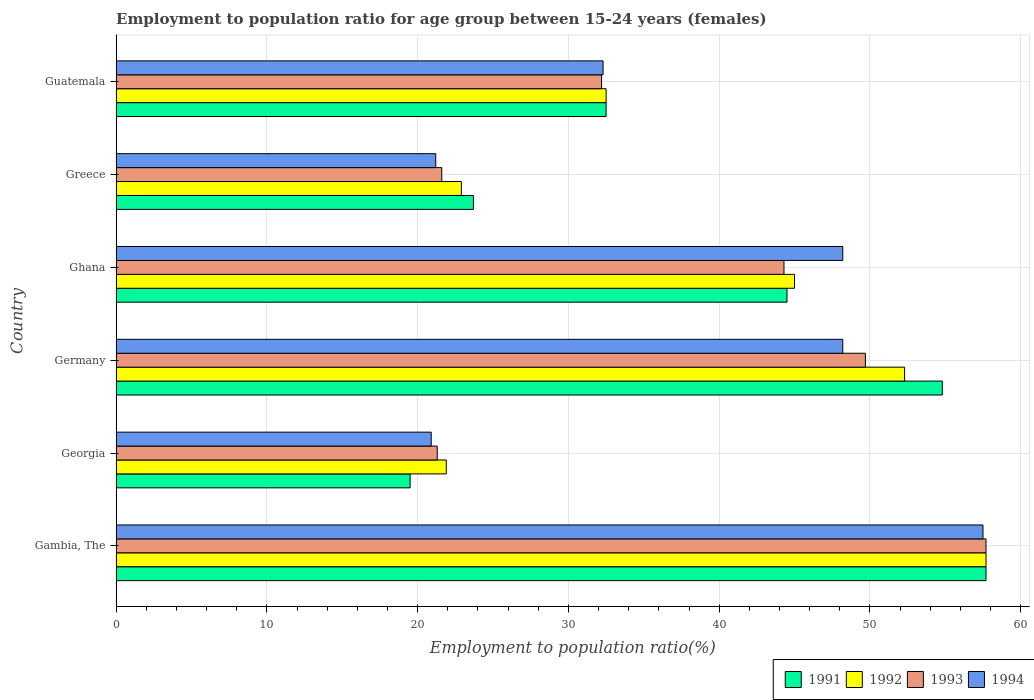Are the number of bars per tick equal to the number of legend labels?
Your answer should be very brief. Yes. In how many cases, is the number of bars for a given country not equal to the number of legend labels?
Your answer should be compact. 0. What is the employment to population ratio in 1994 in Gambia, The?
Give a very brief answer. 57.5. Across all countries, what is the maximum employment to population ratio in 1992?
Your response must be concise. 57.7. Across all countries, what is the minimum employment to population ratio in 1993?
Offer a very short reply. 21.3. In which country was the employment to population ratio in 1994 maximum?
Your answer should be compact. Gambia, The. In which country was the employment to population ratio in 1991 minimum?
Your answer should be compact. Georgia. What is the total employment to population ratio in 1993 in the graph?
Give a very brief answer. 226.8. What is the difference between the employment to population ratio in 1992 in Georgia and that in Germany?
Provide a succinct answer. -30.4. What is the difference between the employment to population ratio in 1992 in Georgia and the employment to population ratio in 1994 in Germany?
Your answer should be compact. -26.3. What is the average employment to population ratio in 1994 per country?
Your answer should be compact. 38.05. What is the difference between the employment to population ratio in 1992 and employment to population ratio in 1993 in Germany?
Your answer should be very brief. 2.6. In how many countries, is the employment to population ratio in 1992 greater than 22 %?
Make the answer very short. 5. What is the ratio of the employment to population ratio in 1991 in Gambia, The to that in Germany?
Ensure brevity in your answer.  1.05. What is the difference between the highest and the second highest employment to population ratio in 1992?
Your response must be concise. 5.4. What is the difference between the highest and the lowest employment to population ratio in 1994?
Provide a succinct answer. 36.6. What does the 2nd bar from the top in Gambia, The represents?
Provide a short and direct response. 1993. What does the 4th bar from the bottom in Germany represents?
Offer a terse response. 1994. How many bars are there?
Make the answer very short. 24. Are all the bars in the graph horizontal?
Your answer should be compact. Yes. Are the values on the major ticks of X-axis written in scientific E-notation?
Give a very brief answer. No. Does the graph contain any zero values?
Provide a succinct answer. No. Does the graph contain grids?
Offer a very short reply. Yes. Where does the legend appear in the graph?
Provide a short and direct response. Bottom right. How many legend labels are there?
Your answer should be compact. 4. How are the legend labels stacked?
Keep it short and to the point. Horizontal. What is the title of the graph?
Offer a very short reply. Employment to population ratio for age group between 15-24 years (females). What is the label or title of the X-axis?
Provide a short and direct response. Employment to population ratio(%). What is the Employment to population ratio(%) in 1991 in Gambia, The?
Provide a succinct answer. 57.7. What is the Employment to population ratio(%) of 1992 in Gambia, The?
Make the answer very short. 57.7. What is the Employment to population ratio(%) in 1993 in Gambia, The?
Your response must be concise. 57.7. What is the Employment to population ratio(%) in 1994 in Gambia, The?
Provide a short and direct response. 57.5. What is the Employment to population ratio(%) in 1991 in Georgia?
Give a very brief answer. 19.5. What is the Employment to population ratio(%) in 1992 in Georgia?
Give a very brief answer. 21.9. What is the Employment to population ratio(%) of 1993 in Georgia?
Provide a succinct answer. 21.3. What is the Employment to population ratio(%) of 1994 in Georgia?
Give a very brief answer. 20.9. What is the Employment to population ratio(%) of 1991 in Germany?
Ensure brevity in your answer.  54.8. What is the Employment to population ratio(%) of 1992 in Germany?
Ensure brevity in your answer.  52.3. What is the Employment to population ratio(%) of 1993 in Germany?
Offer a very short reply. 49.7. What is the Employment to population ratio(%) of 1994 in Germany?
Ensure brevity in your answer.  48.2. What is the Employment to population ratio(%) in 1991 in Ghana?
Ensure brevity in your answer.  44.5. What is the Employment to population ratio(%) in 1993 in Ghana?
Provide a short and direct response. 44.3. What is the Employment to population ratio(%) of 1994 in Ghana?
Offer a terse response. 48.2. What is the Employment to population ratio(%) in 1991 in Greece?
Ensure brevity in your answer.  23.7. What is the Employment to population ratio(%) in 1992 in Greece?
Give a very brief answer. 22.9. What is the Employment to population ratio(%) of 1993 in Greece?
Keep it short and to the point. 21.6. What is the Employment to population ratio(%) of 1994 in Greece?
Your response must be concise. 21.2. What is the Employment to population ratio(%) of 1991 in Guatemala?
Provide a succinct answer. 32.5. What is the Employment to population ratio(%) in 1992 in Guatemala?
Provide a short and direct response. 32.5. What is the Employment to population ratio(%) in 1993 in Guatemala?
Provide a short and direct response. 32.2. What is the Employment to population ratio(%) of 1994 in Guatemala?
Your answer should be very brief. 32.3. Across all countries, what is the maximum Employment to population ratio(%) of 1991?
Ensure brevity in your answer.  57.7. Across all countries, what is the maximum Employment to population ratio(%) of 1992?
Provide a succinct answer. 57.7. Across all countries, what is the maximum Employment to population ratio(%) in 1993?
Ensure brevity in your answer.  57.7. Across all countries, what is the maximum Employment to population ratio(%) of 1994?
Give a very brief answer. 57.5. Across all countries, what is the minimum Employment to population ratio(%) of 1991?
Give a very brief answer. 19.5. Across all countries, what is the minimum Employment to population ratio(%) of 1992?
Your answer should be compact. 21.9. Across all countries, what is the minimum Employment to population ratio(%) in 1993?
Provide a succinct answer. 21.3. Across all countries, what is the minimum Employment to population ratio(%) of 1994?
Your response must be concise. 20.9. What is the total Employment to population ratio(%) in 1991 in the graph?
Your response must be concise. 232.7. What is the total Employment to population ratio(%) in 1992 in the graph?
Give a very brief answer. 232.3. What is the total Employment to population ratio(%) in 1993 in the graph?
Your response must be concise. 226.8. What is the total Employment to population ratio(%) in 1994 in the graph?
Offer a terse response. 228.3. What is the difference between the Employment to population ratio(%) in 1991 in Gambia, The and that in Georgia?
Your response must be concise. 38.2. What is the difference between the Employment to population ratio(%) of 1992 in Gambia, The and that in Georgia?
Offer a very short reply. 35.8. What is the difference between the Employment to population ratio(%) of 1993 in Gambia, The and that in Georgia?
Offer a very short reply. 36.4. What is the difference between the Employment to population ratio(%) in 1994 in Gambia, The and that in Georgia?
Make the answer very short. 36.6. What is the difference between the Employment to population ratio(%) in 1994 in Gambia, The and that in Germany?
Your response must be concise. 9.3. What is the difference between the Employment to population ratio(%) of 1991 in Gambia, The and that in Ghana?
Offer a terse response. 13.2. What is the difference between the Employment to population ratio(%) of 1992 in Gambia, The and that in Ghana?
Provide a succinct answer. 12.7. What is the difference between the Employment to population ratio(%) in 1993 in Gambia, The and that in Ghana?
Your answer should be compact. 13.4. What is the difference between the Employment to population ratio(%) of 1992 in Gambia, The and that in Greece?
Your answer should be compact. 34.8. What is the difference between the Employment to population ratio(%) of 1993 in Gambia, The and that in Greece?
Make the answer very short. 36.1. What is the difference between the Employment to population ratio(%) of 1994 in Gambia, The and that in Greece?
Ensure brevity in your answer.  36.3. What is the difference between the Employment to population ratio(%) of 1991 in Gambia, The and that in Guatemala?
Make the answer very short. 25.2. What is the difference between the Employment to population ratio(%) in 1992 in Gambia, The and that in Guatemala?
Offer a very short reply. 25.2. What is the difference between the Employment to population ratio(%) of 1993 in Gambia, The and that in Guatemala?
Provide a succinct answer. 25.5. What is the difference between the Employment to population ratio(%) of 1994 in Gambia, The and that in Guatemala?
Offer a terse response. 25.2. What is the difference between the Employment to population ratio(%) in 1991 in Georgia and that in Germany?
Provide a succinct answer. -35.3. What is the difference between the Employment to population ratio(%) in 1992 in Georgia and that in Germany?
Keep it short and to the point. -30.4. What is the difference between the Employment to population ratio(%) of 1993 in Georgia and that in Germany?
Give a very brief answer. -28.4. What is the difference between the Employment to population ratio(%) of 1994 in Georgia and that in Germany?
Give a very brief answer. -27.3. What is the difference between the Employment to population ratio(%) in 1991 in Georgia and that in Ghana?
Give a very brief answer. -25. What is the difference between the Employment to population ratio(%) in 1992 in Georgia and that in Ghana?
Ensure brevity in your answer.  -23.1. What is the difference between the Employment to population ratio(%) in 1993 in Georgia and that in Ghana?
Provide a succinct answer. -23. What is the difference between the Employment to population ratio(%) of 1994 in Georgia and that in Ghana?
Make the answer very short. -27.3. What is the difference between the Employment to population ratio(%) in 1993 in Georgia and that in Greece?
Your response must be concise. -0.3. What is the difference between the Employment to population ratio(%) in 1991 in Georgia and that in Guatemala?
Offer a terse response. -13. What is the difference between the Employment to population ratio(%) of 1992 in Georgia and that in Guatemala?
Your response must be concise. -10.6. What is the difference between the Employment to population ratio(%) in 1993 in Georgia and that in Guatemala?
Offer a very short reply. -10.9. What is the difference between the Employment to population ratio(%) of 1994 in Georgia and that in Guatemala?
Provide a short and direct response. -11.4. What is the difference between the Employment to population ratio(%) in 1991 in Germany and that in Ghana?
Ensure brevity in your answer.  10.3. What is the difference between the Employment to population ratio(%) of 1993 in Germany and that in Ghana?
Your response must be concise. 5.4. What is the difference between the Employment to population ratio(%) in 1994 in Germany and that in Ghana?
Ensure brevity in your answer.  0. What is the difference between the Employment to population ratio(%) of 1991 in Germany and that in Greece?
Provide a succinct answer. 31.1. What is the difference between the Employment to population ratio(%) of 1992 in Germany and that in Greece?
Keep it short and to the point. 29.4. What is the difference between the Employment to population ratio(%) of 1993 in Germany and that in Greece?
Keep it short and to the point. 28.1. What is the difference between the Employment to population ratio(%) in 1994 in Germany and that in Greece?
Provide a succinct answer. 27. What is the difference between the Employment to population ratio(%) of 1991 in Germany and that in Guatemala?
Your response must be concise. 22.3. What is the difference between the Employment to population ratio(%) of 1992 in Germany and that in Guatemala?
Offer a very short reply. 19.8. What is the difference between the Employment to population ratio(%) of 1993 in Germany and that in Guatemala?
Your answer should be very brief. 17.5. What is the difference between the Employment to population ratio(%) of 1994 in Germany and that in Guatemala?
Give a very brief answer. 15.9. What is the difference between the Employment to population ratio(%) of 1991 in Ghana and that in Greece?
Keep it short and to the point. 20.8. What is the difference between the Employment to population ratio(%) of 1992 in Ghana and that in Greece?
Ensure brevity in your answer.  22.1. What is the difference between the Employment to population ratio(%) of 1993 in Ghana and that in Greece?
Give a very brief answer. 22.7. What is the difference between the Employment to population ratio(%) in 1994 in Ghana and that in Greece?
Give a very brief answer. 27. What is the difference between the Employment to population ratio(%) in 1993 in Ghana and that in Guatemala?
Your answer should be compact. 12.1. What is the difference between the Employment to population ratio(%) in 1994 in Ghana and that in Guatemala?
Provide a succinct answer. 15.9. What is the difference between the Employment to population ratio(%) of 1993 in Greece and that in Guatemala?
Your answer should be compact. -10.6. What is the difference between the Employment to population ratio(%) in 1994 in Greece and that in Guatemala?
Your answer should be very brief. -11.1. What is the difference between the Employment to population ratio(%) in 1991 in Gambia, The and the Employment to population ratio(%) in 1992 in Georgia?
Your response must be concise. 35.8. What is the difference between the Employment to population ratio(%) in 1991 in Gambia, The and the Employment to population ratio(%) in 1993 in Georgia?
Provide a short and direct response. 36.4. What is the difference between the Employment to population ratio(%) of 1991 in Gambia, The and the Employment to population ratio(%) of 1994 in Georgia?
Provide a succinct answer. 36.8. What is the difference between the Employment to population ratio(%) of 1992 in Gambia, The and the Employment to population ratio(%) of 1993 in Georgia?
Offer a very short reply. 36.4. What is the difference between the Employment to population ratio(%) in 1992 in Gambia, The and the Employment to population ratio(%) in 1994 in Georgia?
Ensure brevity in your answer.  36.8. What is the difference between the Employment to population ratio(%) in 1993 in Gambia, The and the Employment to population ratio(%) in 1994 in Georgia?
Your answer should be compact. 36.8. What is the difference between the Employment to population ratio(%) of 1991 in Gambia, The and the Employment to population ratio(%) of 1993 in Germany?
Offer a very short reply. 8. What is the difference between the Employment to population ratio(%) of 1991 in Gambia, The and the Employment to population ratio(%) of 1994 in Germany?
Provide a short and direct response. 9.5. What is the difference between the Employment to population ratio(%) of 1992 in Gambia, The and the Employment to population ratio(%) of 1993 in Germany?
Your answer should be very brief. 8. What is the difference between the Employment to population ratio(%) in 1991 in Gambia, The and the Employment to population ratio(%) in 1992 in Ghana?
Ensure brevity in your answer.  12.7. What is the difference between the Employment to population ratio(%) of 1993 in Gambia, The and the Employment to population ratio(%) of 1994 in Ghana?
Make the answer very short. 9.5. What is the difference between the Employment to population ratio(%) in 1991 in Gambia, The and the Employment to population ratio(%) in 1992 in Greece?
Your answer should be very brief. 34.8. What is the difference between the Employment to population ratio(%) of 1991 in Gambia, The and the Employment to population ratio(%) of 1993 in Greece?
Give a very brief answer. 36.1. What is the difference between the Employment to population ratio(%) in 1991 in Gambia, The and the Employment to population ratio(%) in 1994 in Greece?
Offer a terse response. 36.5. What is the difference between the Employment to population ratio(%) in 1992 in Gambia, The and the Employment to population ratio(%) in 1993 in Greece?
Keep it short and to the point. 36.1. What is the difference between the Employment to population ratio(%) in 1992 in Gambia, The and the Employment to population ratio(%) in 1994 in Greece?
Provide a short and direct response. 36.5. What is the difference between the Employment to population ratio(%) in 1993 in Gambia, The and the Employment to population ratio(%) in 1994 in Greece?
Your answer should be compact. 36.5. What is the difference between the Employment to population ratio(%) in 1991 in Gambia, The and the Employment to population ratio(%) in 1992 in Guatemala?
Your answer should be very brief. 25.2. What is the difference between the Employment to population ratio(%) of 1991 in Gambia, The and the Employment to population ratio(%) of 1993 in Guatemala?
Provide a succinct answer. 25.5. What is the difference between the Employment to population ratio(%) of 1991 in Gambia, The and the Employment to population ratio(%) of 1994 in Guatemala?
Give a very brief answer. 25.4. What is the difference between the Employment to population ratio(%) of 1992 in Gambia, The and the Employment to population ratio(%) of 1994 in Guatemala?
Your answer should be compact. 25.4. What is the difference between the Employment to population ratio(%) of 1993 in Gambia, The and the Employment to population ratio(%) of 1994 in Guatemala?
Provide a short and direct response. 25.4. What is the difference between the Employment to population ratio(%) of 1991 in Georgia and the Employment to population ratio(%) of 1992 in Germany?
Provide a succinct answer. -32.8. What is the difference between the Employment to population ratio(%) in 1991 in Georgia and the Employment to population ratio(%) in 1993 in Germany?
Ensure brevity in your answer.  -30.2. What is the difference between the Employment to population ratio(%) of 1991 in Georgia and the Employment to population ratio(%) of 1994 in Germany?
Provide a short and direct response. -28.7. What is the difference between the Employment to population ratio(%) in 1992 in Georgia and the Employment to population ratio(%) in 1993 in Germany?
Offer a terse response. -27.8. What is the difference between the Employment to population ratio(%) in 1992 in Georgia and the Employment to population ratio(%) in 1994 in Germany?
Make the answer very short. -26.3. What is the difference between the Employment to population ratio(%) in 1993 in Georgia and the Employment to population ratio(%) in 1994 in Germany?
Provide a succinct answer. -26.9. What is the difference between the Employment to population ratio(%) of 1991 in Georgia and the Employment to population ratio(%) of 1992 in Ghana?
Make the answer very short. -25.5. What is the difference between the Employment to population ratio(%) of 1991 in Georgia and the Employment to population ratio(%) of 1993 in Ghana?
Your answer should be compact. -24.8. What is the difference between the Employment to population ratio(%) of 1991 in Georgia and the Employment to population ratio(%) of 1994 in Ghana?
Make the answer very short. -28.7. What is the difference between the Employment to population ratio(%) of 1992 in Georgia and the Employment to population ratio(%) of 1993 in Ghana?
Ensure brevity in your answer.  -22.4. What is the difference between the Employment to population ratio(%) of 1992 in Georgia and the Employment to population ratio(%) of 1994 in Ghana?
Make the answer very short. -26.3. What is the difference between the Employment to population ratio(%) in 1993 in Georgia and the Employment to population ratio(%) in 1994 in Ghana?
Provide a short and direct response. -26.9. What is the difference between the Employment to population ratio(%) of 1991 in Georgia and the Employment to population ratio(%) of 1992 in Greece?
Provide a succinct answer. -3.4. What is the difference between the Employment to population ratio(%) in 1991 in Georgia and the Employment to population ratio(%) in 1994 in Greece?
Your answer should be compact. -1.7. What is the difference between the Employment to population ratio(%) in 1992 in Georgia and the Employment to population ratio(%) in 1994 in Greece?
Offer a very short reply. 0.7. What is the difference between the Employment to population ratio(%) in 1991 in Georgia and the Employment to population ratio(%) in 1992 in Guatemala?
Ensure brevity in your answer.  -13. What is the difference between the Employment to population ratio(%) in 1991 in Georgia and the Employment to population ratio(%) in 1994 in Guatemala?
Make the answer very short. -12.8. What is the difference between the Employment to population ratio(%) in 1992 in Georgia and the Employment to population ratio(%) in 1993 in Guatemala?
Offer a very short reply. -10.3. What is the difference between the Employment to population ratio(%) in 1991 in Germany and the Employment to population ratio(%) in 1992 in Ghana?
Offer a terse response. 9.8. What is the difference between the Employment to population ratio(%) of 1991 in Germany and the Employment to population ratio(%) of 1992 in Greece?
Keep it short and to the point. 31.9. What is the difference between the Employment to population ratio(%) in 1991 in Germany and the Employment to population ratio(%) in 1993 in Greece?
Your answer should be very brief. 33.2. What is the difference between the Employment to population ratio(%) in 1991 in Germany and the Employment to population ratio(%) in 1994 in Greece?
Offer a terse response. 33.6. What is the difference between the Employment to population ratio(%) in 1992 in Germany and the Employment to population ratio(%) in 1993 in Greece?
Your answer should be compact. 30.7. What is the difference between the Employment to population ratio(%) in 1992 in Germany and the Employment to population ratio(%) in 1994 in Greece?
Your response must be concise. 31.1. What is the difference between the Employment to population ratio(%) in 1993 in Germany and the Employment to population ratio(%) in 1994 in Greece?
Your answer should be compact. 28.5. What is the difference between the Employment to population ratio(%) in 1991 in Germany and the Employment to population ratio(%) in 1992 in Guatemala?
Give a very brief answer. 22.3. What is the difference between the Employment to population ratio(%) in 1991 in Germany and the Employment to population ratio(%) in 1993 in Guatemala?
Offer a terse response. 22.6. What is the difference between the Employment to population ratio(%) in 1991 in Germany and the Employment to population ratio(%) in 1994 in Guatemala?
Provide a short and direct response. 22.5. What is the difference between the Employment to population ratio(%) of 1992 in Germany and the Employment to population ratio(%) of 1993 in Guatemala?
Provide a short and direct response. 20.1. What is the difference between the Employment to population ratio(%) of 1993 in Germany and the Employment to population ratio(%) of 1994 in Guatemala?
Make the answer very short. 17.4. What is the difference between the Employment to population ratio(%) of 1991 in Ghana and the Employment to population ratio(%) of 1992 in Greece?
Provide a short and direct response. 21.6. What is the difference between the Employment to population ratio(%) in 1991 in Ghana and the Employment to population ratio(%) in 1993 in Greece?
Your answer should be very brief. 22.9. What is the difference between the Employment to population ratio(%) of 1991 in Ghana and the Employment to population ratio(%) of 1994 in Greece?
Keep it short and to the point. 23.3. What is the difference between the Employment to population ratio(%) of 1992 in Ghana and the Employment to population ratio(%) of 1993 in Greece?
Your response must be concise. 23.4. What is the difference between the Employment to population ratio(%) of 1992 in Ghana and the Employment to population ratio(%) of 1994 in Greece?
Your answer should be compact. 23.8. What is the difference between the Employment to population ratio(%) of 1993 in Ghana and the Employment to population ratio(%) of 1994 in Greece?
Offer a terse response. 23.1. What is the difference between the Employment to population ratio(%) in 1991 in Ghana and the Employment to population ratio(%) in 1992 in Guatemala?
Keep it short and to the point. 12. What is the difference between the Employment to population ratio(%) of 1992 in Ghana and the Employment to population ratio(%) of 1994 in Guatemala?
Offer a terse response. 12.7. What is the difference between the Employment to population ratio(%) in 1993 in Ghana and the Employment to population ratio(%) in 1994 in Guatemala?
Offer a terse response. 12. What is the difference between the Employment to population ratio(%) of 1991 in Greece and the Employment to population ratio(%) of 1994 in Guatemala?
Provide a succinct answer. -8.6. What is the difference between the Employment to population ratio(%) in 1992 in Greece and the Employment to population ratio(%) in 1993 in Guatemala?
Offer a very short reply. -9.3. What is the average Employment to population ratio(%) in 1991 per country?
Offer a very short reply. 38.78. What is the average Employment to population ratio(%) of 1992 per country?
Provide a short and direct response. 38.72. What is the average Employment to population ratio(%) of 1993 per country?
Ensure brevity in your answer.  37.8. What is the average Employment to population ratio(%) in 1994 per country?
Keep it short and to the point. 38.05. What is the difference between the Employment to population ratio(%) of 1991 and Employment to population ratio(%) of 1992 in Gambia, The?
Your response must be concise. 0. What is the difference between the Employment to population ratio(%) of 1992 and Employment to population ratio(%) of 1994 in Gambia, The?
Make the answer very short. 0.2. What is the difference between the Employment to population ratio(%) in 1993 and Employment to population ratio(%) in 1994 in Gambia, The?
Keep it short and to the point. 0.2. What is the difference between the Employment to population ratio(%) of 1991 and Employment to population ratio(%) of 1992 in Georgia?
Your answer should be compact. -2.4. What is the difference between the Employment to population ratio(%) of 1992 and Employment to population ratio(%) of 1994 in Georgia?
Your response must be concise. 1. What is the difference between the Employment to population ratio(%) of 1993 and Employment to population ratio(%) of 1994 in Georgia?
Make the answer very short. 0.4. What is the difference between the Employment to population ratio(%) of 1992 and Employment to population ratio(%) of 1993 in Germany?
Your answer should be compact. 2.6. What is the difference between the Employment to population ratio(%) in 1991 and Employment to population ratio(%) in 1992 in Ghana?
Give a very brief answer. -0.5. What is the difference between the Employment to population ratio(%) of 1992 and Employment to population ratio(%) of 1993 in Ghana?
Keep it short and to the point. 0.7. What is the difference between the Employment to population ratio(%) of 1991 and Employment to population ratio(%) of 1993 in Greece?
Offer a very short reply. 2.1. What is the difference between the Employment to population ratio(%) in 1992 and Employment to population ratio(%) in 1993 in Greece?
Offer a terse response. 1.3. What is the difference between the Employment to population ratio(%) of 1993 and Employment to population ratio(%) of 1994 in Greece?
Make the answer very short. 0.4. What is the difference between the Employment to population ratio(%) in 1991 and Employment to population ratio(%) in 1992 in Guatemala?
Offer a very short reply. 0. What is the difference between the Employment to population ratio(%) of 1991 and Employment to population ratio(%) of 1994 in Guatemala?
Ensure brevity in your answer.  0.2. What is the difference between the Employment to population ratio(%) of 1992 and Employment to population ratio(%) of 1993 in Guatemala?
Keep it short and to the point. 0.3. What is the difference between the Employment to population ratio(%) of 1993 and Employment to population ratio(%) of 1994 in Guatemala?
Your response must be concise. -0.1. What is the ratio of the Employment to population ratio(%) in 1991 in Gambia, The to that in Georgia?
Offer a terse response. 2.96. What is the ratio of the Employment to population ratio(%) in 1992 in Gambia, The to that in Georgia?
Make the answer very short. 2.63. What is the ratio of the Employment to population ratio(%) of 1993 in Gambia, The to that in Georgia?
Give a very brief answer. 2.71. What is the ratio of the Employment to population ratio(%) in 1994 in Gambia, The to that in Georgia?
Your answer should be compact. 2.75. What is the ratio of the Employment to population ratio(%) of 1991 in Gambia, The to that in Germany?
Your answer should be very brief. 1.05. What is the ratio of the Employment to population ratio(%) in 1992 in Gambia, The to that in Germany?
Offer a terse response. 1.1. What is the ratio of the Employment to population ratio(%) in 1993 in Gambia, The to that in Germany?
Make the answer very short. 1.16. What is the ratio of the Employment to population ratio(%) of 1994 in Gambia, The to that in Germany?
Offer a very short reply. 1.19. What is the ratio of the Employment to population ratio(%) of 1991 in Gambia, The to that in Ghana?
Your answer should be very brief. 1.3. What is the ratio of the Employment to population ratio(%) in 1992 in Gambia, The to that in Ghana?
Give a very brief answer. 1.28. What is the ratio of the Employment to population ratio(%) of 1993 in Gambia, The to that in Ghana?
Your answer should be compact. 1.3. What is the ratio of the Employment to population ratio(%) of 1994 in Gambia, The to that in Ghana?
Keep it short and to the point. 1.19. What is the ratio of the Employment to population ratio(%) of 1991 in Gambia, The to that in Greece?
Your answer should be very brief. 2.43. What is the ratio of the Employment to population ratio(%) in 1992 in Gambia, The to that in Greece?
Keep it short and to the point. 2.52. What is the ratio of the Employment to population ratio(%) of 1993 in Gambia, The to that in Greece?
Your answer should be compact. 2.67. What is the ratio of the Employment to population ratio(%) in 1994 in Gambia, The to that in Greece?
Your answer should be very brief. 2.71. What is the ratio of the Employment to population ratio(%) in 1991 in Gambia, The to that in Guatemala?
Keep it short and to the point. 1.78. What is the ratio of the Employment to population ratio(%) of 1992 in Gambia, The to that in Guatemala?
Your answer should be very brief. 1.78. What is the ratio of the Employment to population ratio(%) of 1993 in Gambia, The to that in Guatemala?
Make the answer very short. 1.79. What is the ratio of the Employment to population ratio(%) in 1994 in Gambia, The to that in Guatemala?
Offer a terse response. 1.78. What is the ratio of the Employment to population ratio(%) of 1991 in Georgia to that in Germany?
Ensure brevity in your answer.  0.36. What is the ratio of the Employment to population ratio(%) in 1992 in Georgia to that in Germany?
Offer a very short reply. 0.42. What is the ratio of the Employment to population ratio(%) in 1993 in Georgia to that in Germany?
Keep it short and to the point. 0.43. What is the ratio of the Employment to population ratio(%) of 1994 in Georgia to that in Germany?
Give a very brief answer. 0.43. What is the ratio of the Employment to population ratio(%) in 1991 in Georgia to that in Ghana?
Ensure brevity in your answer.  0.44. What is the ratio of the Employment to population ratio(%) of 1992 in Georgia to that in Ghana?
Your answer should be very brief. 0.49. What is the ratio of the Employment to population ratio(%) in 1993 in Georgia to that in Ghana?
Provide a succinct answer. 0.48. What is the ratio of the Employment to population ratio(%) of 1994 in Georgia to that in Ghana?
Give a very brief answer. 0.43. What is the ratio of the Employment to population ratio(%) of 1991 in Georgia to that in Greece?
Make the answer very short. 0.82. What is the ratio of the Employment to population ratio(%) of 1992 in Georgia to that in Greece?
Ensure brevity in your answer.  0.96. What is the ratio of the Employment to population ratio(%) in 1993 in Georgia to that in Greece?
Your answer should be compact. 0.99. What is the ratio of the Employment to population ratio(%) in 1994 in Georgia to that in Greece?
Make the answer very short. 0.99. What is the ratio of the Employment to population ratio(%) in 1991 in Georgia to that in Guatemala?
Provide a succinct answer. 0.6. What is the ratio of the Employment to population ratio(%) in 1992 in Georgia to that in Guatemala?
Offer a terse response. 0.67. What is the ratio of the Employment to population ratio(%) in 1993 in Georgia to that in Guatemala?
Provide a short and direct response. 0.66. What is the ratio of the Employment to population ratio(%) in 1994 in Georgia to that in Guatemala?
Keep it short and to the point. 0.65. What is the ratio of the Employment to population ratio(%) of 1991 in Germany to that in Ghana?
Your answer should be compact. 1.23. What is the ratio of the Employment to population ratio(%) of 1992 in Germany to that in Ghana?
Give a very brief answer. 1.16. What is the ratio of the Employment to population ratio(%) of 1993 in Germany to that in Ghana?
Your response must be concise. 1.12. What is the ratio of the Employment to population ratio(%) in 1991 in Germany to that in Greece?
Provide a succinct answer. 2.31. What is the ratio of the Employment to population ratio(%) of 1992 in Germany to that in Greece?
Your answer should be very brief. 2.28. What is the ratio of the Employment to population ratio(%) of 1993 in Germany to that in Greece?
Offer a terse response. 2.3. What is the ratio of the Employment to population ratio(%) of 1994 in Germany to that in Greece?
Give a very brief answer. 2.27. What is the ratio of the Employment to population ratio(%) in 1991 in Germany to that in Guatemala?
Offer a terse response. 1.69. What is the ratio of the Employment to population ratio(%) of 1992 in Germany to that in Guatemala?
Ensure brevity in your answer.  1.61. What is the ratio of the Employment to population ratio(%) of 1993 in Germany to that in Guatemala?
Ensure brevity in your answer.  1.54. What is the ratio of the Employment to population ratio(%) in 1994 in Germany to that in Guatemala?
Your response must be concise. 1.49. What is the ratio of the Employment to population ratio(%) of 1991 in Ghana to that in Greece?
Ensure brevity in your answer.  1.88. What is the ratio of the Employment to population ratio(%) in 1992 in Ghana to that in Greece?
Your answer should be very brief. 1.97. What is the ratio of the Employment to population ratio(%) in 1993 in Ghana to that in Greece?
Your answer should be compact. 2.05. What is the ratio of the Employment to population ratio(%) in 1994 in Ghana to that in Greece?
Your response must be concise. 2.27. What is the ratio of the Employment to population ratio(%) in 1991 in Ghana to that in Guatemala?
Provide a succinct answer. 1.37. What is the ratio of the Employment to population ratio(%) in 1992 in Ghana to that in Guatemala?
Make the answer very short. 1.38. What is the ratio of the Employment to population ratio(%) of 1993 in Ghana to that in Guatemala?
Your answer should be compact. 1.38. What is the ratio of the Employment to population ratio(%) in 1994 in Ghana to that in Guatemala?
Your answer should be very brief. 1.49. What is the ratio of the Employment to population ratio(%) of 1991 in Greece to that in Guatemala?
Offer a very short reply. 0.73. What is the ratio of the Employment to population ratio(%) in 1992 in Greece to that in Guatemala?
Your response must be concise. 0.7. What is the ratio of the Employment to population ratio(%) of 1993 in Greece to that in Guatemala?
Provide a short and direct response. 0.67. What is the ratio of the Employment to population ratio(%) of 1994 in Greece to that in Guatemala?
Ensure brevity in your answer.  0.66. What is the difference between the highest and the second highest Employment to population ratio(%) of 1992?
Ensure brevity in your answer.  5.4. What is the difference between the highest and the lowest Employment to population ratio(%) in 1991?
Your answer should be compact. 38.2. What is the difference between the highest and the lowest Employment to population ratio(%) of 1992?
Provide a short and direct response. 35.8. What is the difference between the highest and the lowest Employment to population ratio(%) of 1993?
Make the answer very short. 36.4. What is the difference between the highest and the lowest Employment to population ratio(%) in 1994?
Ensure brevity in your answer.  36.6. 